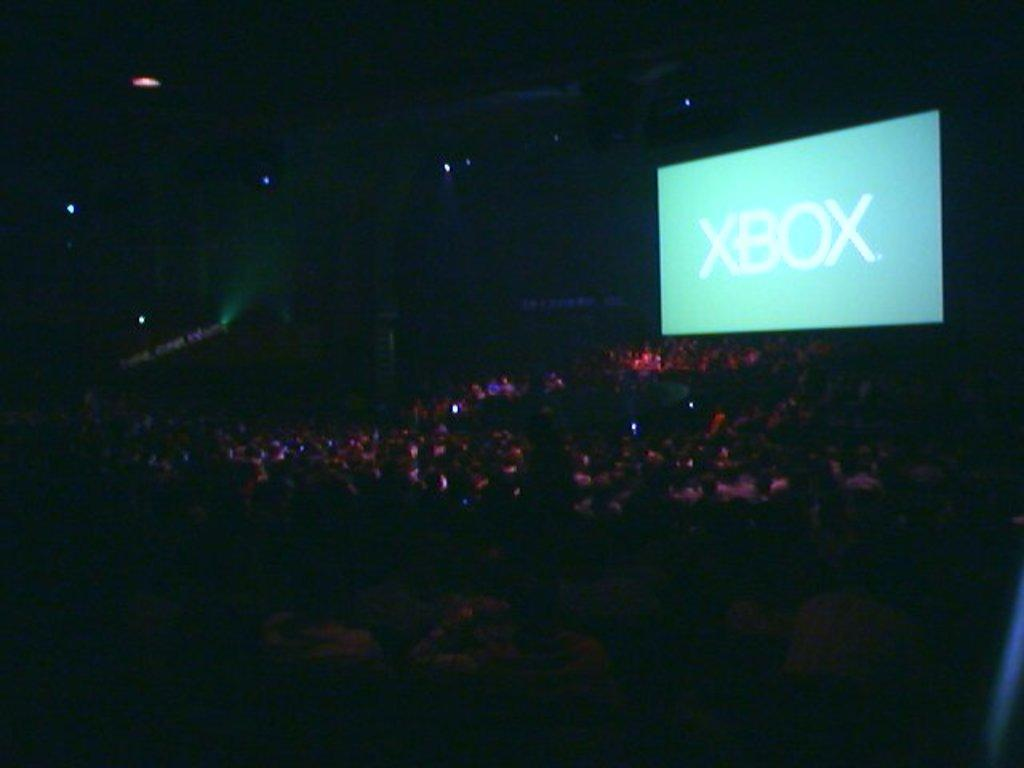What are the people in the image doing? There is a group of people sitting in the image. What electronic device is present in the image? There is a digital screen in the image. What type of illumination can be seen in the image? There are lights in the image. How would you describe the overall lighting in the image? The background of the image is dark. What role does the father play in the image? There is no mention of a father or any specific roles in the image. 